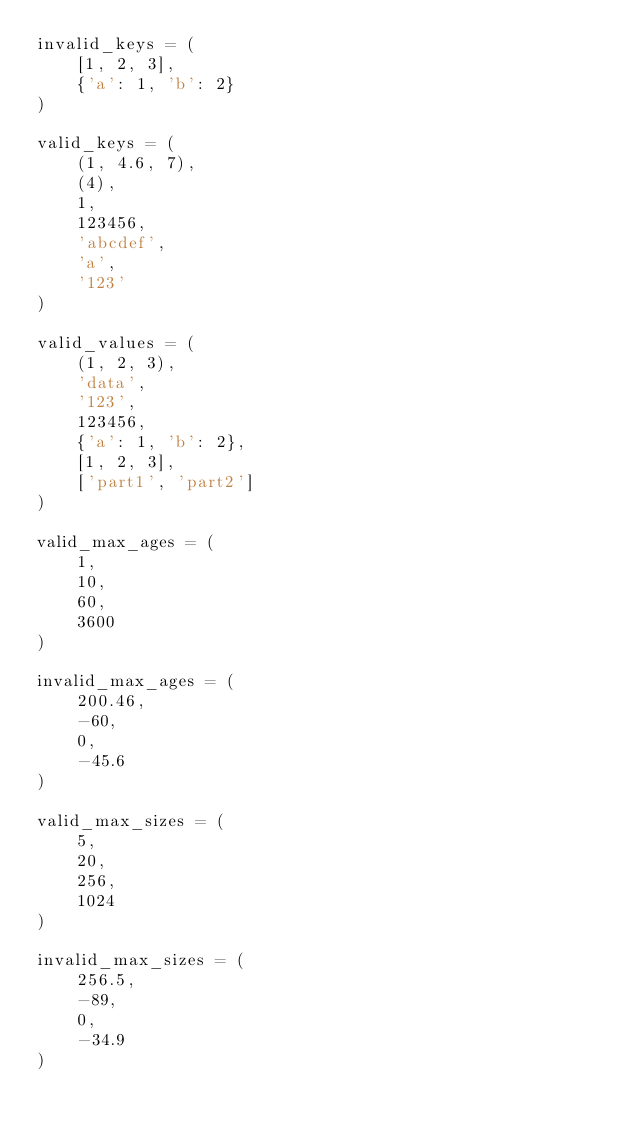<code> <loc_0><loc_0><loc_500><loc_500><_Python_>invalid_keys = (
    [1, 2, 3],
    {'a': 1, 'b': 2}
)

valid_keys = (
    (1, 4.6, 7),
    (4),
    1,
    123456,
    'abcdef',
    'a',
    '123'
)

valid_values = (
    (1, 2, 3),
    'data',
    '123',
    123456,
    {'a': 1, 'b': 2},
    [1, 2, 3],
    ['part1', 'part2']
)

valid_max_ages = (
    1,
    10,
    60,
    3600
)

invalid_max_ages = (
    200.46,
    -60,
    0,
    -45.6
)

valid_max_sizes = (
    5,
    20,
    256,
    1024
)

invalid_max_sizes = (
    256.5,
    -89,
    0,
    -34.9
)</code> 